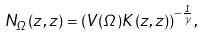<formula> <loc_0><loc_0><loc_500><loc_500>N _ { \Omega } ( z , z ) = ( V ( \Omega ) K ( z , z ) ) ^ { - \frac { 1 } { \gamma } } ,</formula> 